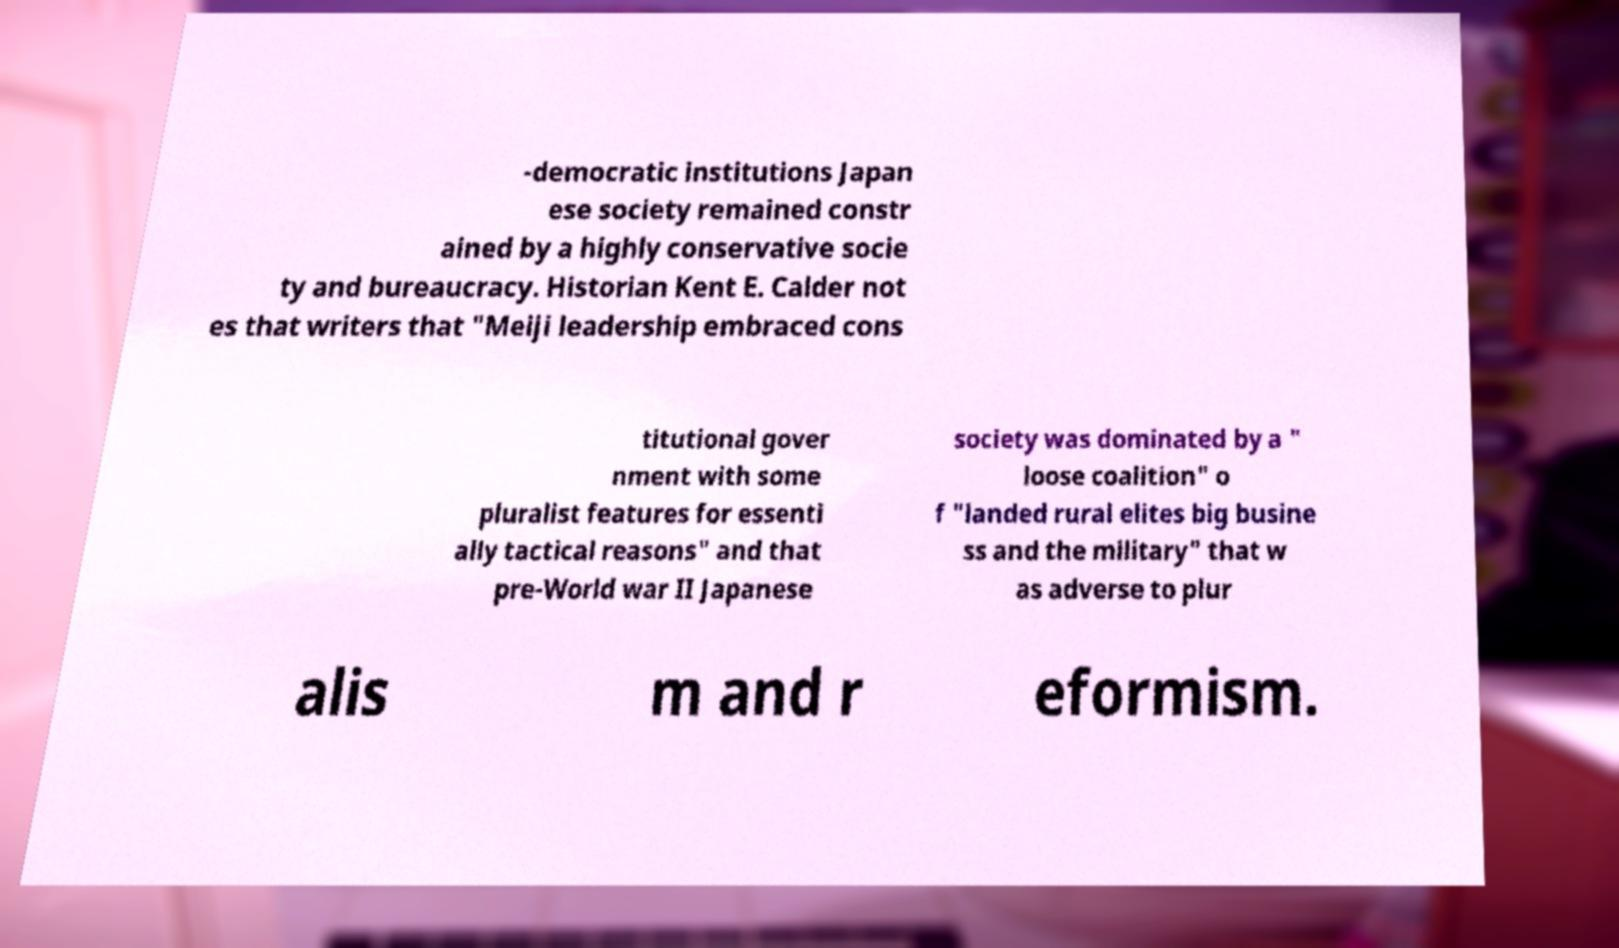I need the written content from this picture converted into text. Can you do that? -democratic institutions Japan ese society remained constr ained by a highly conservative socie ty and bureaucracy. Historian Kent E. Calder not es that writers that "Meiji leadership embraced cons titutional gover nment with some pluralist features for essenti ally tactical reasons" and that pre-World war II Japanese society was dominated by a " loose coalition" o f "landed rural elites big busine ss and the military" that w as adverse to plur alis m and r eformism. 